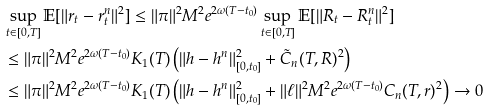<formula> <loc_0><loc_0><loc_500><loc_500>& \sup _ { t \in [ 0 , T ] } \mathbb { E } [ \| r _ { t } - r _ { t } ^ { n } \| ^ { 2 } ] \leq \| \pi \| ^ { 2 } M ^ { 2 } e ^ { 2 \omega ( T - t _ { 0 } ) } \sup _ { t \in [ 0 , T ] } \mathbb { E } [ \| R _ { t } - R _ { t } ^ { n } \| ^ { 2 } ] \\ & \leq \| \pi \| ^ { 2 } M ^ { 2 } e ^ { 2 \omega ( T - t _ { 0 } ) } K _ { 1 } ( T ) \left ( \| h - h ^ { n } \| _ { [ 0 , t _ { 0 } ] } ^ { 2 } + \tilde { C } _ { n } ( T , R ) ^ { 2 } \right ) \\ & \leq \| \pi \| ^ { 2 } M ^ { 2 } e ^ { 2 \omega ( T - t _ { 0 } ) } K _ { 1 } ( T ) \left ( \| h - h ^ { n } \| _ { [ 0 , t _ { 0 } ] } ^ { 2 } + \| \ell \| ^ { 2 } M ^ { 2 } e ^ { 2 \omega ( T - t _ { 0 } ) } C _ { n } ( T , r ) ^ { 2 } \right ) \rightarrow 0</formula> 